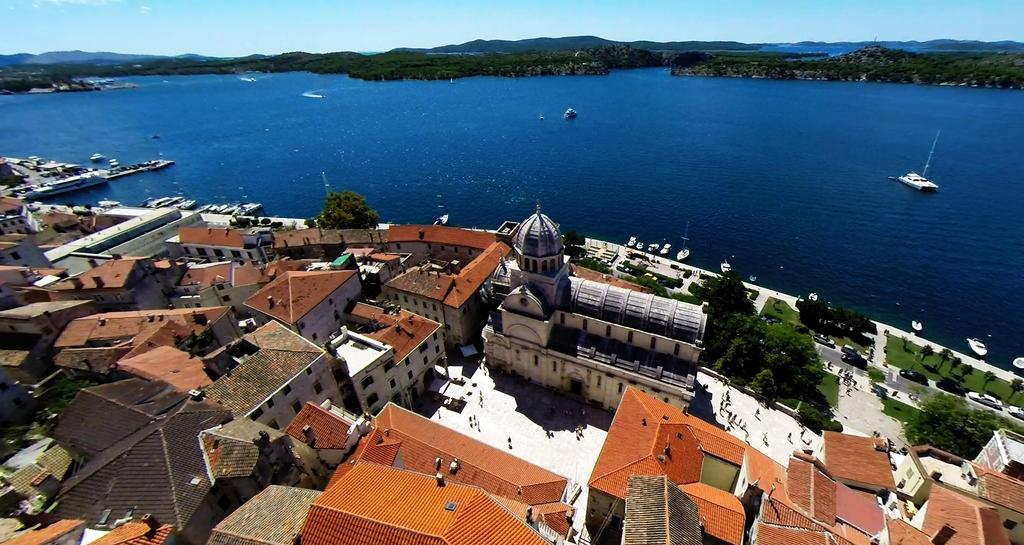What type of structures can be seen in the image? There are houses in the image. What natural elements are present in the image? There are trees and mountains visible in the image. Who or what can be seen in the image? There are people and ships on a river in the image. What part of the natural environment is visible in the image? The sky is visible in the image. What type of wool is being spun by the people in the image? There is no wool or spinning activity present in the image. How does the butter contribute to the memory of the people in the image? There is no butter or memory-related activity present in the image. 